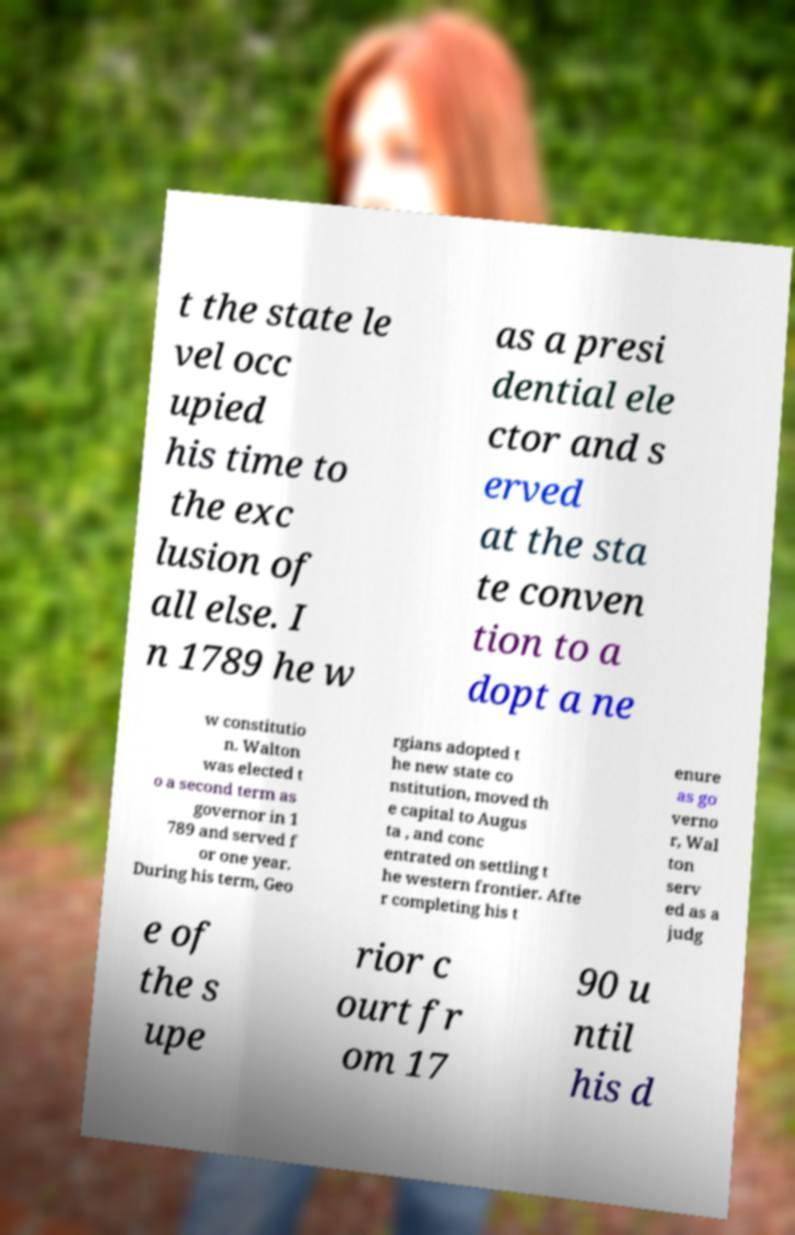Please read and relay the text visible in this image. What does it say? t the state le vel occ upied his time to the exc lusion of all else. I n 1789 he w as a presi dential ele ctor and s erved at the sta te conven tion to a dopt a ne w constitutio n. Walton was elected t o a second term as governor in 1 789 and served f or one year. During his term, Geo rgians adopted t he new state co nstitution, moved th e capital to Augus ta , and conc entrated on settling t he western frontier. Afte r completing his t enure as go verno r, Wal ton serv ed as a judg e of the s upe rior c ourt fr om 17 90 u ntil his d 